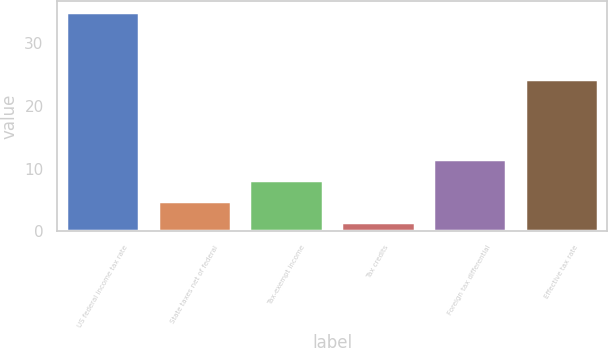Convert chart to OTSL. <chart><loc_0><loc_0><loc_500><loc_500><bar_chart><fcel>US federal income tax rate<fcel>State taxes net of federal<fcel>Tax-exempt income<fcel>Tax credits<fcel>Foreign tax differential<fcel>Effective tax rate<nl><fcel>35<fcel>4.85<fcel>8.2<fcel>1.5<fcel>11.55<fcel>24.3<nl></chart> 